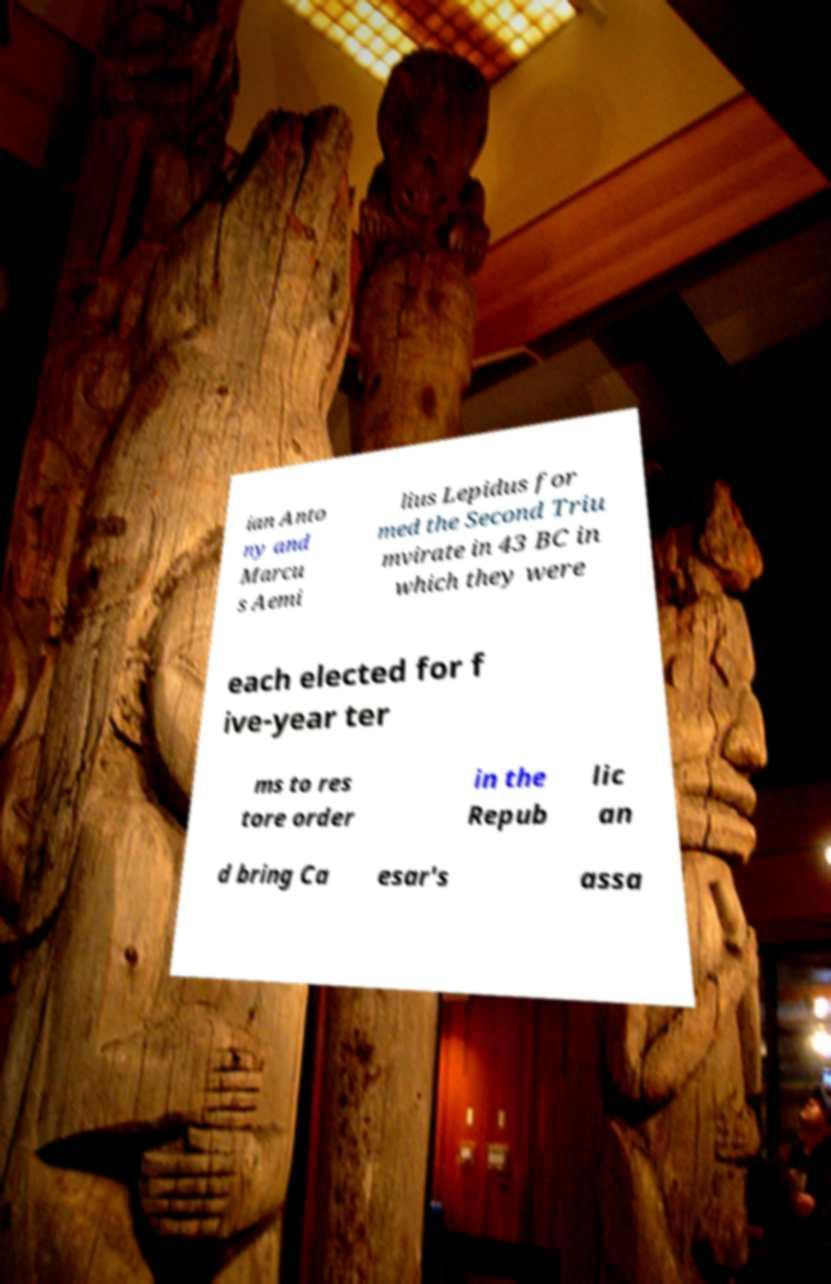There's text embedded in this image that I need extracted. Can you transcribe it verbatim? ian Anto ny and Marcu s Aemi lius Lepidus for med the Second Triu mvirate in 43 BC in which they were each elected for f ive-year ter ms to res tore order in the Repub lic an d bring Ca esar's assa 